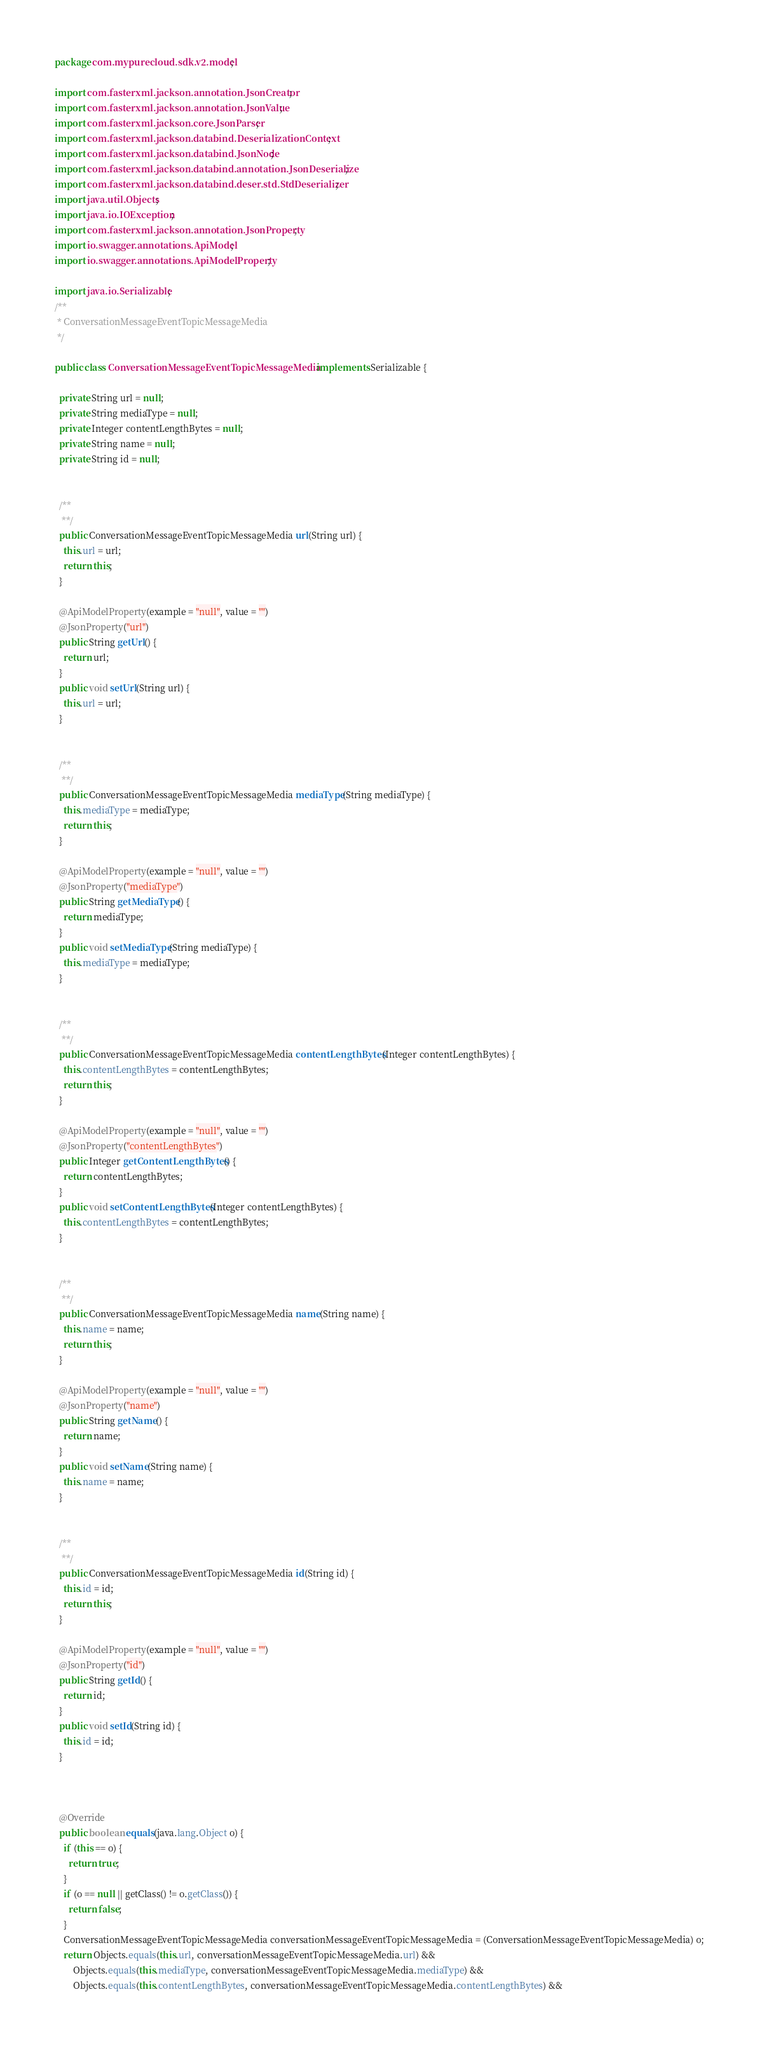Convert code to text. <code><loc_0><loc_0><loc_500><loc_500><_Java_>package com.mypurecloud.sdk.v2.model;

import com.fasterxml.jackson.annotation.JsonCreator;
import com.fasterxml.jackson.annotation.JsonValue;
import com.fasterxml.jackson.core.JsonParser;
import com.fasterxml.jackson.databind.DeserializationContext;
import com.fasterxml.jackson.databind.JsonNode;
import com.fasterxml.jackson.databind.annotation.JsonDeserialize;
import com.fasterxml.jackson.databind.deser.std.StdDeserializer;
import java.util.Objects;
import java.io.IOException;
import com.fasterxml.jackson.annotation.JsonProperty;
import io.swagger.annotations.ApiModel;
import io.swagger.annotations.ApiModelProperty;

import java.io.Serializable;
/**
 * ConversationMessageEventTopicMessageMedia
 */

public class ConversationMessageEventTopicMessageMedia  implements Serializable {
  
  private String url = null;
  private String mediaType = null;
  private Integer contentLengthBytes = null;
  private String name = null;
  private String id = null;

  
  /**
   **/
  public ConversationMessageEventTopicMessageMedia url(String url) {
    this.url = url;
    return this;
  }
  
  @ApiModelProperty(example = "null", value = "")
  @JsonProperty("url")
  public String getUrl() {
    return url;
  }
  public void setUrl(String url) {
    this.url = url;
  }

  
  /**
   **/
  public ConversationMessageEventTopicMessageMedia mediaType(String mediaType) {
    this.mediaType = mediaType;
    return this;
  }
  
  @ApiModelProperty(example = "null", value = "")
  @JsonProperty("mediaType")
  public String getMediaType() {
    return mediaType;
  }
  public void setMediaType(String mediaType) {
    this.mediaType = mediaType;
  }

  
  /**
   **/
  public ConversationMessageEventTopicMessageMedia contentLengthBytes(Integer contentLengthBytes) {
    this.contentLengthBytes = contentLengthBytes;
    return this;
  }
  
  @ApiModelProperty(example = "null", value = "")
  @JsonProperty("contentLengthBytes")
  public Integer getContentLengthBytes() {
    return contentLengthBytes;
  }
  public void setContentLengthBytes(Integer contentLengthBytes) {
    this.contentLengthBytes = contentLengthBytes;
  }

  
  /**
   **/
  public ConversationMessageEventTopicMessageMedia name(String name) {
    this.name = name;
    return this;
  }
  
  @ApiModelProperty(example = "null", value = "")
  @JsonProperty("name")
  public String getName() {
    return name;
  }
  public void setName(String name) {
    this.name = name;
  }

  
  /**
   **/
  public ConversationMessageEventTopicMessageMedia id(String id) {
    this.id = id;
    return this;
  }
  
  @ApiModelProperty(example = "null", value = "")
  @JsonProperty("id")
  public String getId() {
    return id;
  }
  public void setId(String id) {
    this.id = id;
  }

  

  @Override
  public boolean equals(java.lang.Object o) {
    if (this == o) {
      return true;
    }
    if (o == null || getClass() != o.getClass()) {
      return false;
    }
    ConversationMessageEventTopicMessageMedia conversationMessageEventTopicMessageMedia = (ConversationMessageEventTopicMessageMedia) o;
    return Objects.equals(this.url, conversationMessageEventTopicMessageMedia.url) &&
        Objects.equals(this.mediaType, conversationMessageEventTopicMessageMedia.mediaType) &&
        Objects.equals(this.contentLengthBytes, conversationMessageEventTopicMessageMedia.contentLengthBytes) &&</code> 